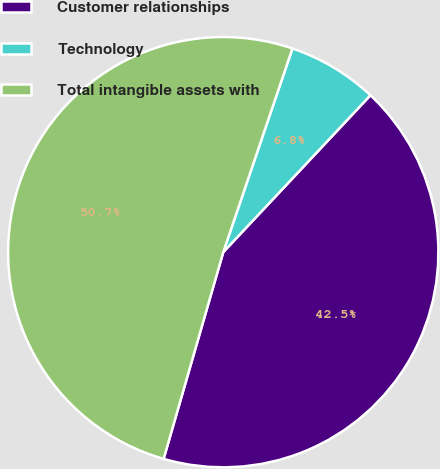Convert chart to OTSL. <chart><loc_0><loc_0><loc_500><loc_500><pie_chart><fcel>Customer relationships<fcel>Technology<fcel>Total intangible assets with<nl><fcel>42.48%<fcel>6.78%<fcel>50.74%<nl></chart> 